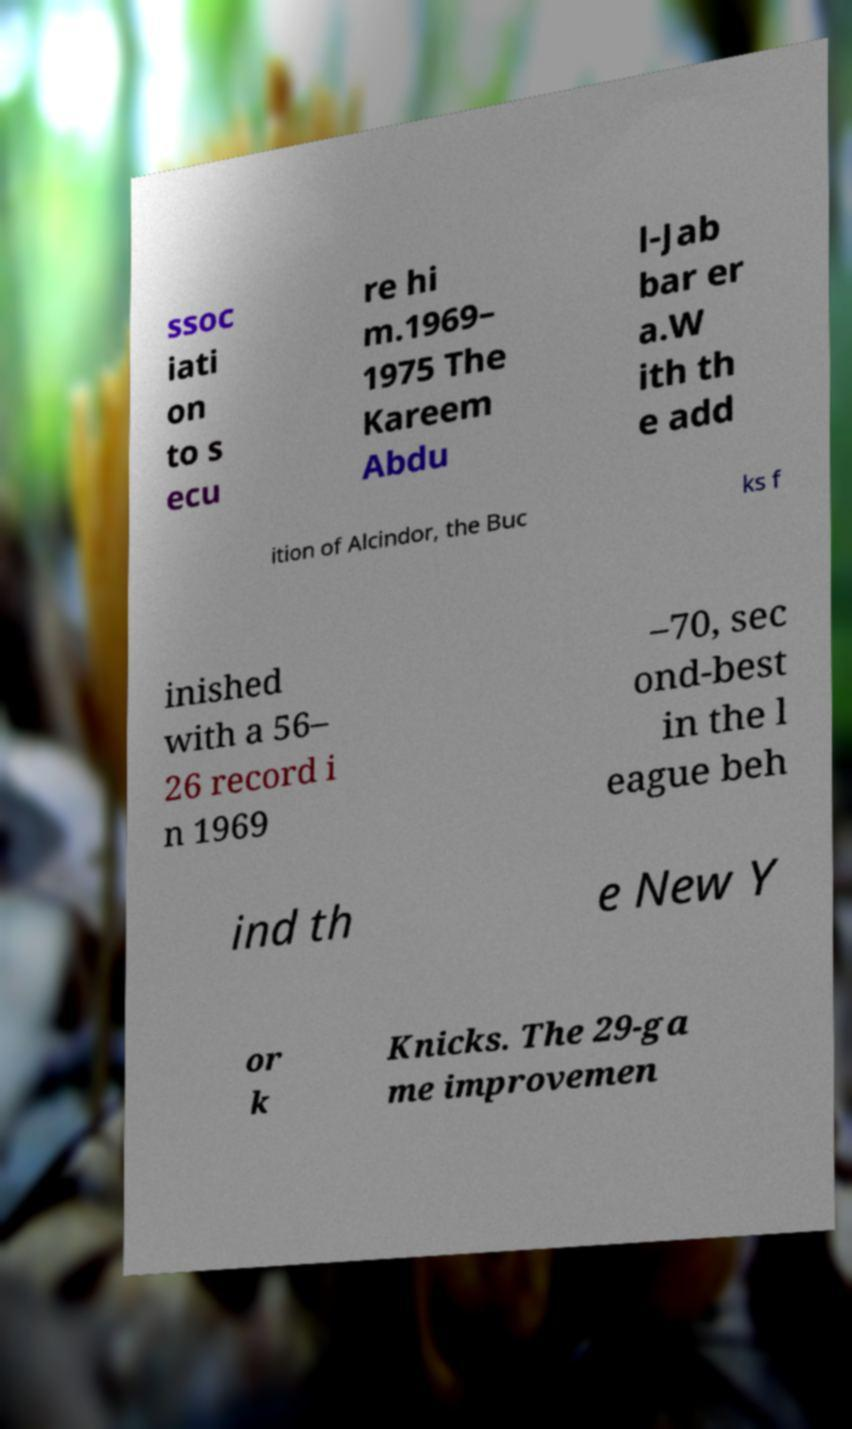Can you accurately transcribe the text from the provided image for me? ssoc iati on to s ecu re hi m.1969– 1975 The Kareem Abdu l-Jab bar er a.W ith th e add ition of Alcindor, the Buc ks f inished with a 56– 26 record i n 1969 –70, sec ond-best in the l eague beh ind th e New Y or k Knicks. The 29-ga me improvemen 